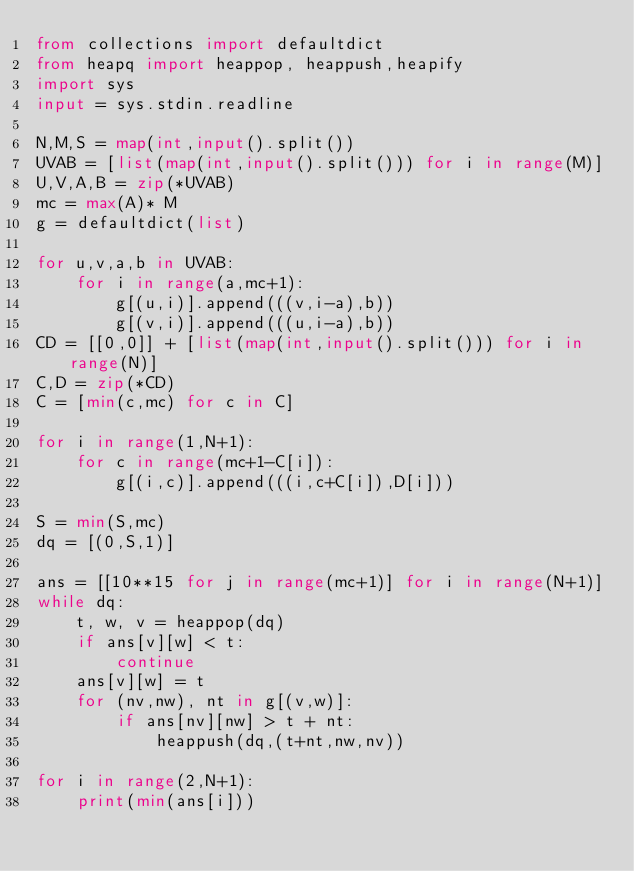Convert code to text. <code><loc_0><loc_0><loc_500><loc_500><_Python_>from collections import defaultdict
from heapq import heappop, heappush,heapify
import sys
input = sys.stdin.readline

N,M,S = map(int,input().split())
UVAB = [list(map(int,input().split())) for i in range(M)]
U,V,A,B = zip(*UVAB)
mc = max(A)* M
g = defaultdict(list)

for u,v,a,b in UVAB:
    for i in range(a,mc+1):
        g[(u,i)].append(((v,i-a),b))
        g[(v,i)].append(((u,i-a),b))
CD = [[0,0]] + [list(map(int,input().split())) for i in range(N)]
C,D = zip(*CD)
C = [min(c,mc) for c in C]

for i in range(1,N+1):
    for c in range(mc+1-C[i]):
        g[(i,c)].append(((i,c+C[i]),D[i]))

S = min(S,mc)
dq = [(0,S,1)]

ans = [[10**15 for j in range(mc+1)] for i in range(N+1)]
while dq:
    t, w, v = heappop(dq)
    if ans[v][w] < t:
        continue
    ans[v][w] = t
    for (nv,nw), nt in g[(v,w)]:
        if ans[nv][nw] > t + nt:
            heappush(dq,(t+nt,nw,nv))

for i in range(2,N+1):
    print(min(ans[i]))



</code> 